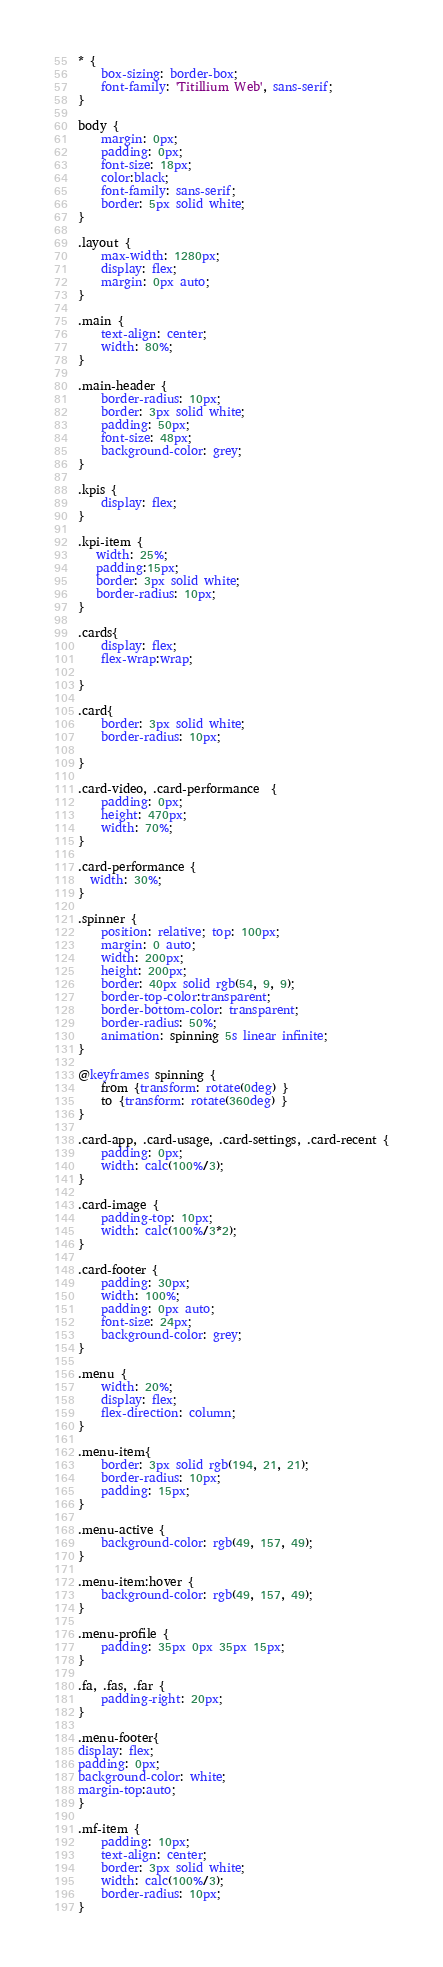<code> <loc_0><loc_0><loc_500><loc_500><_CSS_>* {
    box-sizing: border-box;
    font-family: 'Titillium Web', sans-serif;
}

body {
    margin: 0px;
    padding: 0px;
    font-size: 18px;
    color:black;
    font-family: sans-serif;
    border: 5px solid white;
}

.layout { 
    max-width: 1280px;
    display: flex;
    margin: 0px auto;
}

.main {
    text-align: center;
    width: 80%;
}

.main-header {
    border-radius: 10px;
    border: 3px solid white;
    padding: 50px;
    font-size: 48px;
    background-color: grey;
}

.kpis {
    display: flex;
}

.kpi-item {
   width: 25%;
   padding:15px;
   border: 3px solid white;
   border-radius: 10px;
}

.cards{
    display: flex;
    flex-wrap:wrap;
    
}

.card{
    border: 3px solid white;
    border-radius: 10px;
    
}

.card-video, .card-performance  {
    padding: 0px;
    height: 470px;
    width: 70%;
}

.card-performance {
  width: 30%;
}

.spinner {
    position: relative; top: 100px;
    margin: 0 auto;
    width: 200px;
    height: 200px;
    border: 40px solid rgb(54, 9, 9);
    border-top-color:transparent;
    border-bottom-color: transparent;
    border-radius: 50%;
    animation: spinning 5s linear infinite;
}

@keyframes spinning {
    from {transform: rotate(0deg) }
    to {transform: rotate(360deg) }
}

.card-app, .card-usage, .card-settings, .card-recent {
    padding: 0px;
    width: calc(100%/3);
}

.card-image {
    padding-top: 10px;
    width: calc(100%/3*2);
}

.card-footer {
    padding: 30px;
    width: 100%;
    padding: 0px auto;
    font-size: 24px;
    background-color: grey;
}

.menu {
    width: 20%;
    display: flex;
    flex-direction: column;
}

.menu-item{
    border: 3px solid rgb(194, 21, 21);
    border-radius: 10px;
    padding: 15px;
}

.menu-active {
    background-color: rgb(49, 157, 49);
}

.menu-item:hover {
    background-color: rgb(49, 157, 49);
}

.menu-profile {
    padding: 35px 0px 35px 15px;
}

.fa, .fas, .far {
    padding-right: 20px;
}

.menu-footer{
display: flex;
padding: 0px;
background-color: white;
margin-top:auto;
}

.mf-item {
    padding: 10px;
    text-align: center;
    border: 3px solid white;
    width: calc(100%/3);
    border-radius: 10px;
}
</code> 